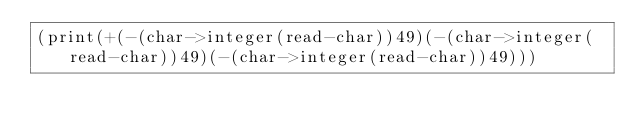<code> <loc_0><loc_0><loc_500><loc_500><_Scheme_>(print(+(-(char->integer(read-char))49)(-(char->integer(read-char))49)(-(char->integer(read-char))49)))</code> 